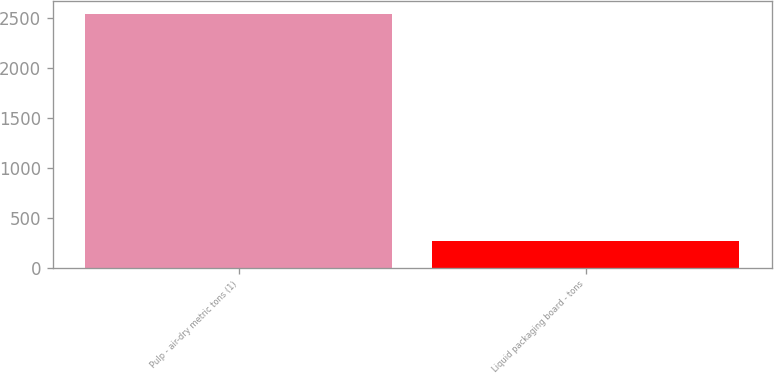Convert chart to OTSL. <chart><loc_0><loc_0><loc_500><loc_500><bar_chart><fcel>Pulp - air-dry metric tons (1)<fcel>Liquid packaging board - tons<nl><fcel>2546<fcel>266<nl></chart> 